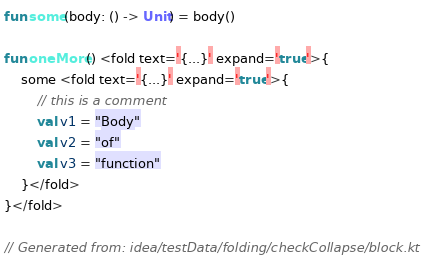<code> <loc_0><loc_0><loc_500><loc_500><_Kotlin_>fun some(body: () -> Unit) = body()

fun oneMore() <fold text='{...}' expand='true'>{
    some <fold text='{...}' expand='true'>{
        // this is a comment
        val v1 = "Body"
        val v2 = "of"
        val v3 = "function"
    }</fold>
}</fold>

// Generated from: idea/testData/folding/checkCollapse/block.kt</code> 